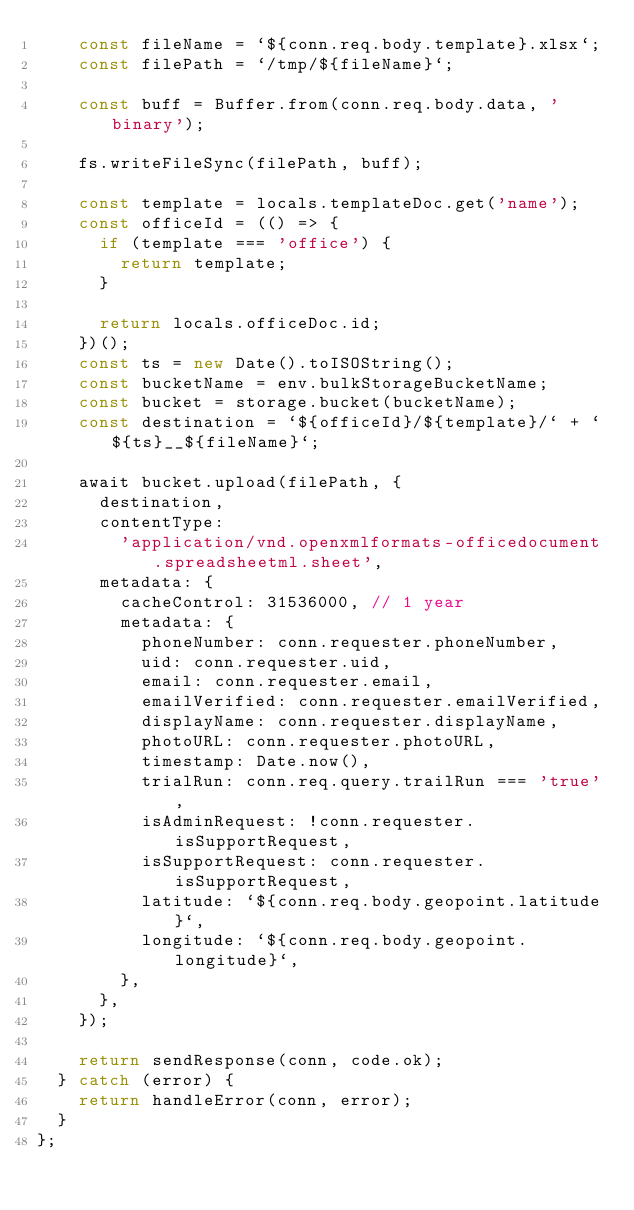<code> <loc_0><loc_0><loc_500><loc_500><_JavaScript_>    const fileName = `${conn.req.body.template}.xlsx`;
    const filePath = `/tmp/${fileName}`;

    const buff = Buffer.from(conn.req.body.data, 'binary');

    fs.writeFileSync(filePath, buff);

    const template = locals.templateDoc.get('name');
    const officeId = (() => {
      if (template === 'office') {
        return template;
      }

      return locals.officeDoc.id;
    })();
    const ts = new Date().toISOString();
    const bucketName = env.bulkStorageBucketName;
    const bucket = storage.bucket(bucketName);
    const destination = `${officeId}/${template}/` + `${ts}__${fileName}`;

    await bucket.upload(filePath, {
      destination,
      contentType:
        'application/vnd.openxmlformats-officedocument.spreadsheetml.sheet',
      metadata: {
        cacheControl: 31536000, // 1 year
        metadata: {
          phoneNumber: conn.requester.phoneNumber,
          uid: conn.requester.uid,
          email: conn.requester.email,
          emailVerified: conn.requester.emailVerified,
          displayName: conn.requester.displayName,
          photoURL: conn.requester.photoURL,
          timestamp: Date.now(),
          trialRun: conn.req.query.trailRun === 'true',
          isAdminRequest: !conn.requester.isSupportRequest,
          isSupportRequest: conn.requester.isSupportRequest,
          latitude: `${conn.req.body.geopoint.latitude}`,
          longitude: `${conn.req.body.geopoint.longitude}`,
        },
      },
    });

    return sendResponse(conn, code.ok);
  } catch (error) {
    return handleError(conn, error);
  }
};
</code> 